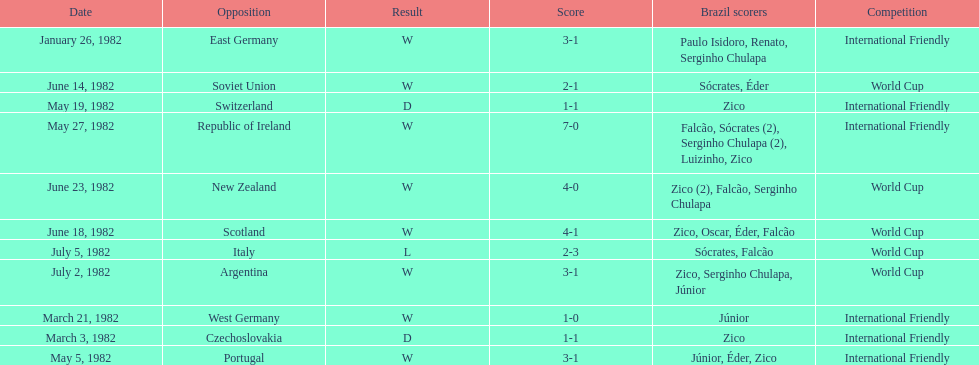Who won on january 26, 1982 and may 27, 1982? Brazil. 